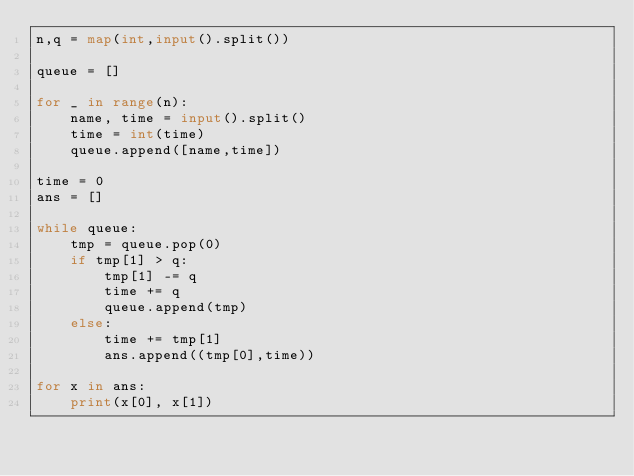Convert code to text. <code><loc_0><loc_0><loc_500><loc_500><_Python_>n,q = map(int,input().split())

queue = []

for _ in range(n):
    name, time = input().split()
    time = int(time)
    queue.append([name,time])

time = 0
ans = []

while queue:
    tmp = queue.pop(0)
    if tmp[1] > q:
        tmp[1] -= q
        time += q
        queue.append(tmp)
    else:
        time += tmp[1]
        ans.append((tmp[0],time))

for x in ans:
    print(x[0], x[1])
</code> 